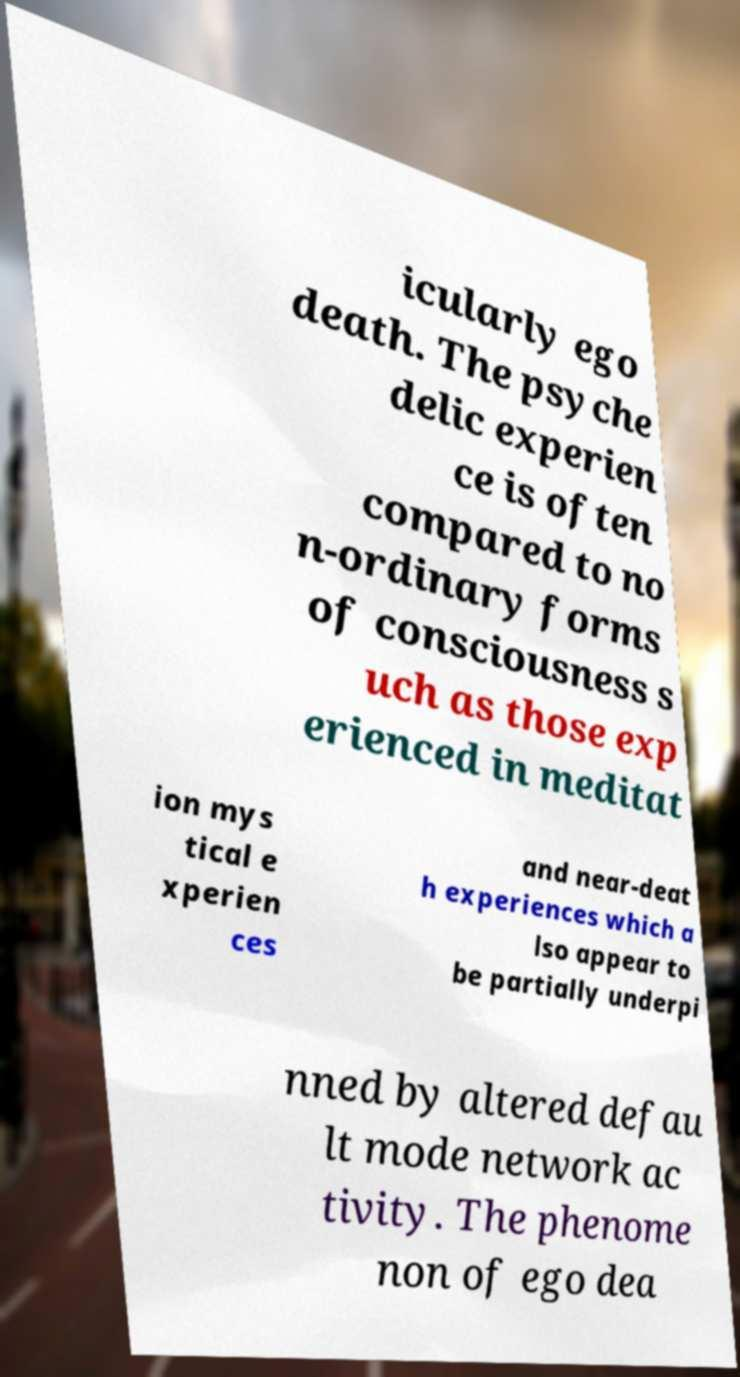Can you accurately transcribe the text from the provided image for me? icularly ego death. The psyche delic experien ce is often compared to no n-ordinary forms of consciousness s uch as those exp erienced in meditat ion mys tical e xperien ces and near-deat h experiences which a lso appear to be partially underpi nned by altered defau lt mode network ac tivity. The phenome non of ego dea 